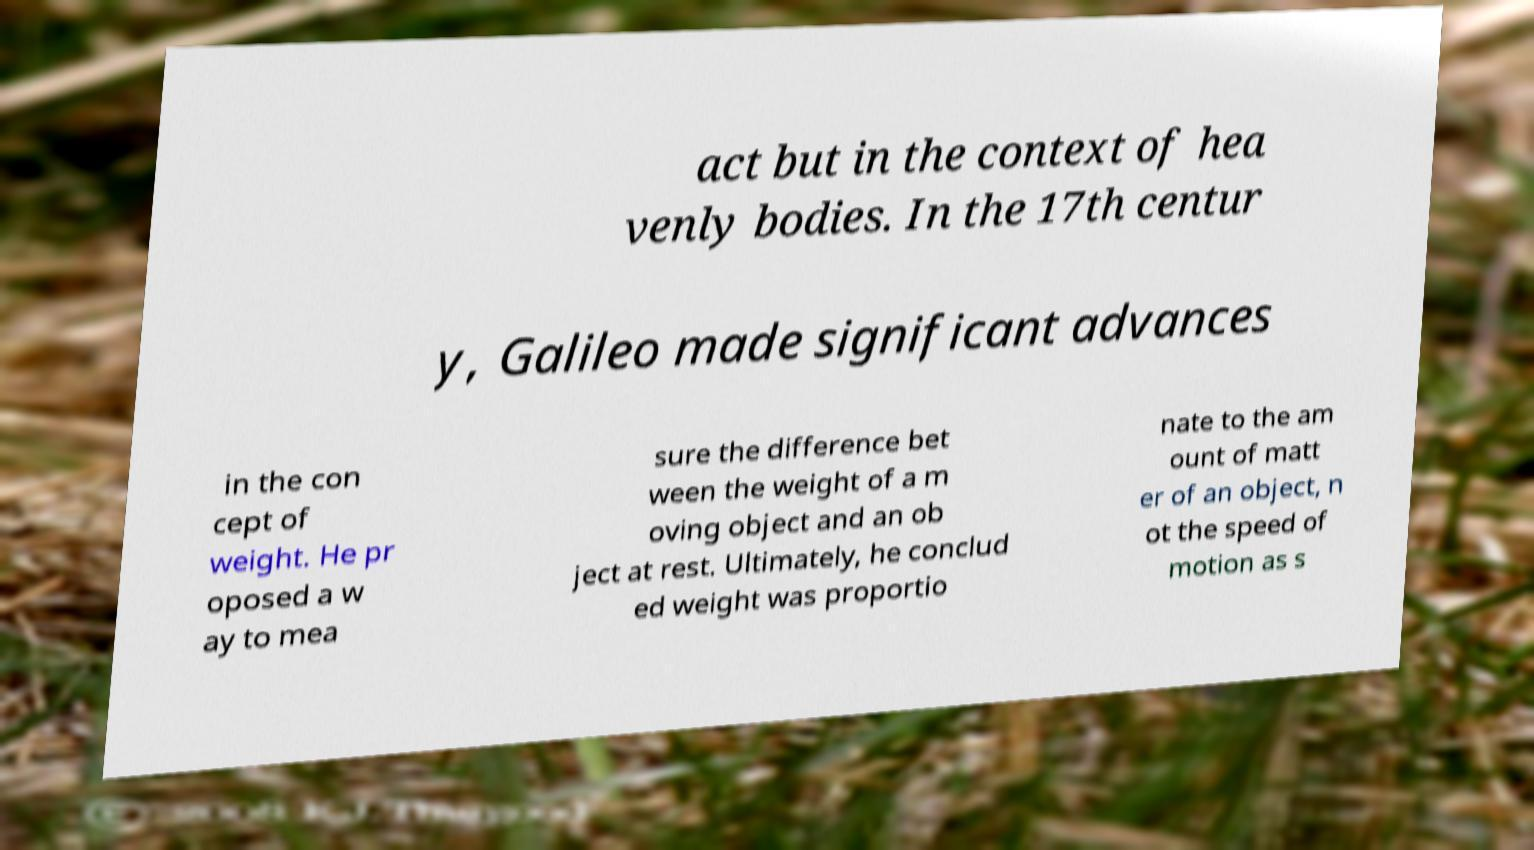Could you extract and type out the text from this image? act but in the context of hea venly bodies. In the 17th centur y, Galileo made significant advances in the con cept of weight. He pr oposed a w ay to mea sure the difference bet ween the weight of a m oving object and an ob ject at rest. Ultimately, he conclud ed weight was proportio nate to the am ount of matt er of an object, n ot the speed of motion as s 